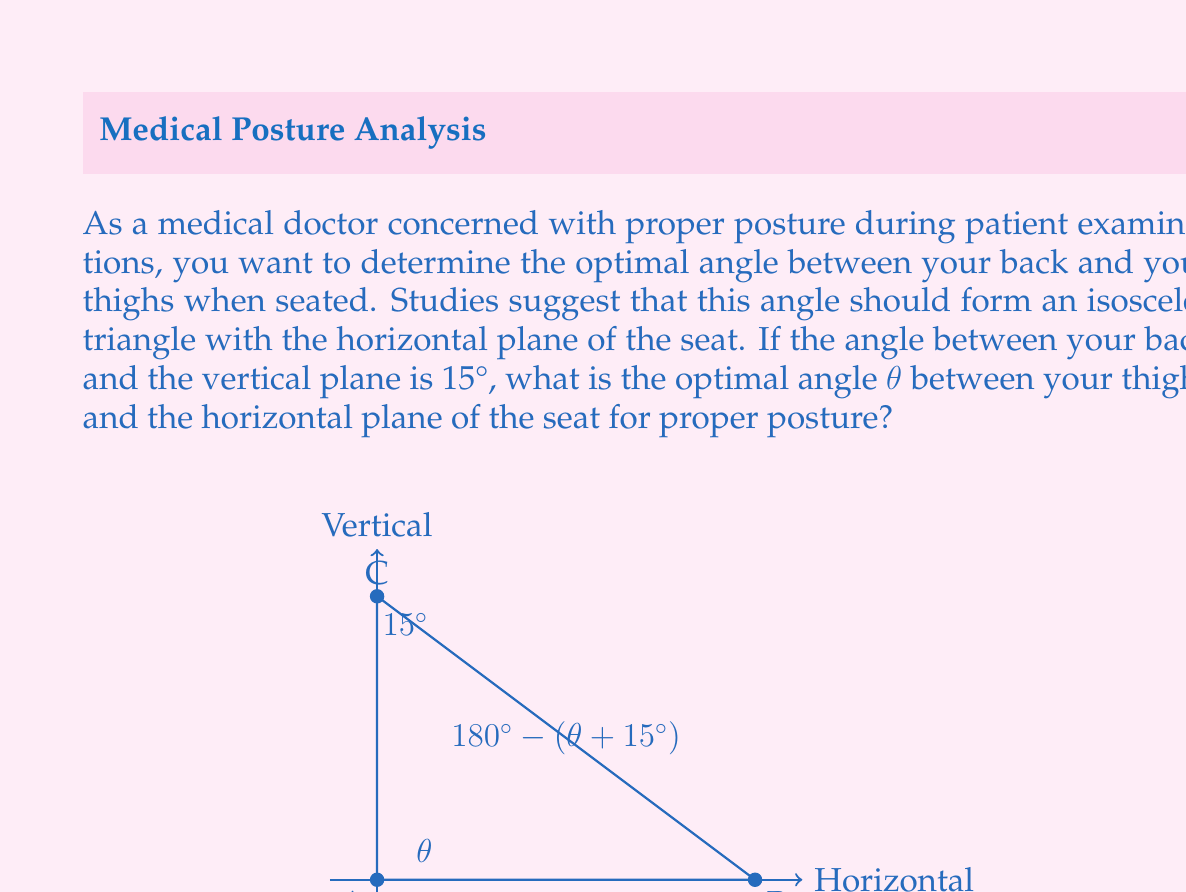Can you solve this math problem? Let's approach this step-by-step:

1) In an isosceles triangle, two angles are equal. In this case, the angle between the back and the seat ($90° + 15° = 105°$) should be equal to the angle between the thighs and the back.

2) Let's call the angle we're looking for $\theta$. This is the angle between the thighs and the horizontal plane.

3) The sum of angles in a triangle is always 180°. We can set up an equation:

   $\theta + (90° + 15°) + (90° - \theta) = 180°$

4) Simplify:
   
   $\theta + 105° + 90° - \theta = 180°$
   $105° + 90° = 180°$
   $195° = 180°$

5) This equation is true, confirming that our setup is correct.

6) Now, we know that the angle between the back and the thighs should be $105°$ (to make it isosceles).

7) Therefore:
   
   $90° - \theta = 105°$

8) Solve for $\theta$:
   
   $-\theta = 15°$
   $\theta = -15°$

9) Since angles are typically expressed as positive values in this context, we take the absolute value:

   $\theta = 15°$

This means the optimal angle between the thighs and the horizontal plane is 15°.
Answer: The optimal angle $\theta$ between the thighs and the horizontal plane of the seat for proper posture is $15°$. 